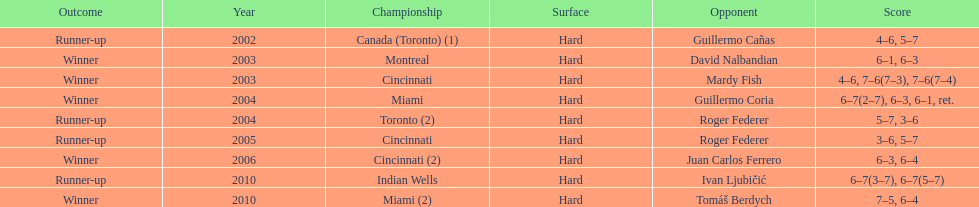What is the maximum number of successive victories he has achieved? 3. 